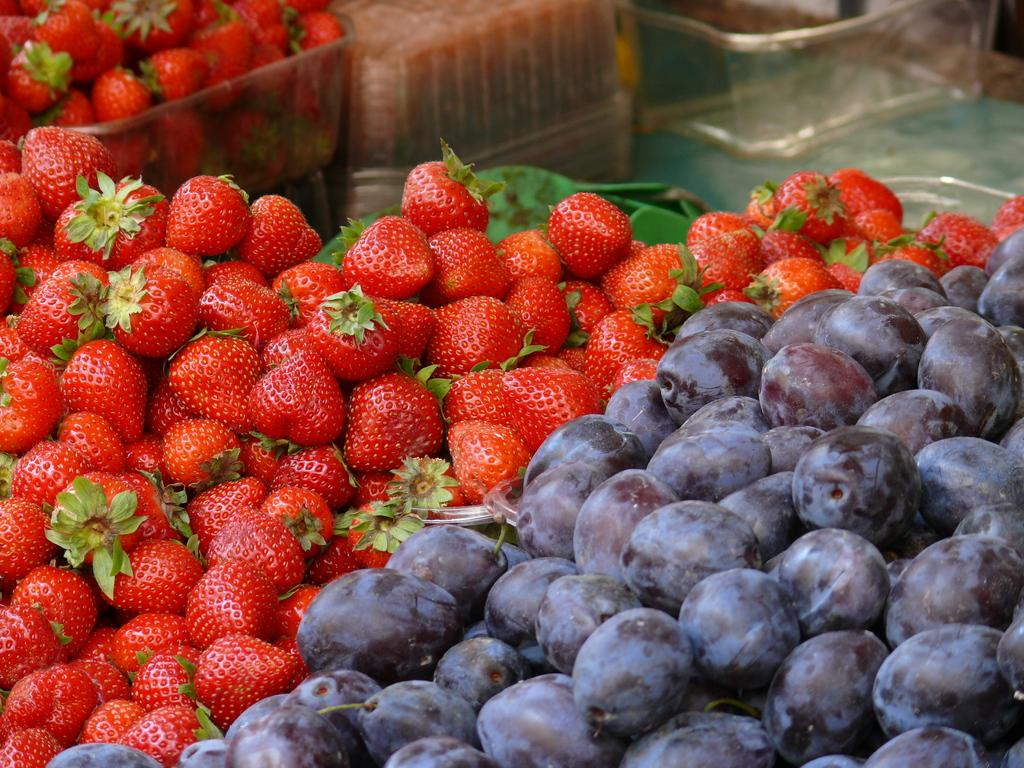What type of fruit is on the left side of the image? There are strawberries on the left side of the image. What type of fruit is on the right side of the image? There are black grapes on the right side of the image. What type of container is visible in the image? There are glass trays visible in the image. What flavor of kittens can be seen playing with a rake in the image? There are no kittens or rakes present in the image, so this question cannot be answered. 